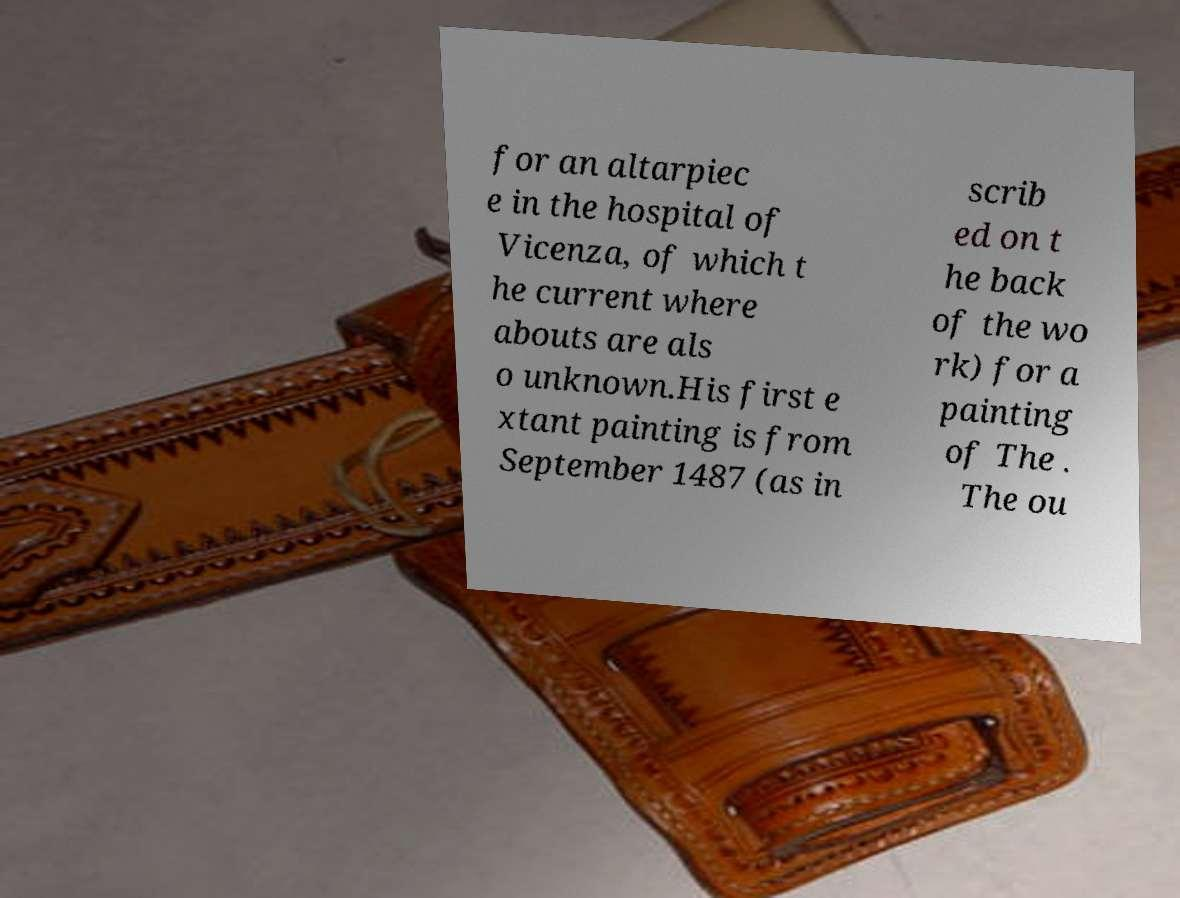Can you accurately transcribe the text from the provided image for me? for an altarpiec e in the hospital of Vicenza, of which t he current where abouts are als o unknown.His first e xtant painting is from September 1487 (as in scrib ed on t he back of the wo rk) for a painting of The . The ou 